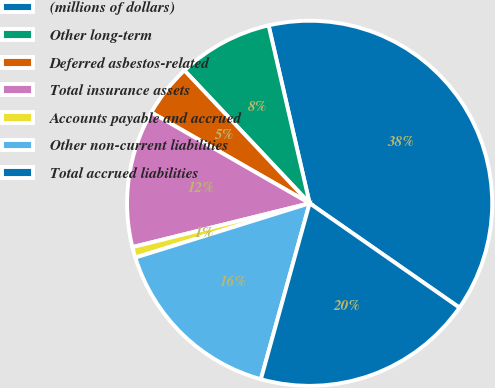Convert chart to OTSL. <chart><loc_0><loc_0><loc_500><loc_500><pie_chart><fcel>(millions of dollars)<fcel>Other long-term<fcel>Deferred asbestos-related<fcel>Total insurance assets<fcel>Accounts payable and accrued<fcel>Other non-current liabilities<fcel>Total accrued liabilities<nl><fcel>38.29%<fcel>8.42%<fcel>4.68%<fcel>12.15%<fcel>0.95%<fcel>15.89%<fcel>19.62%<nl></chart> 